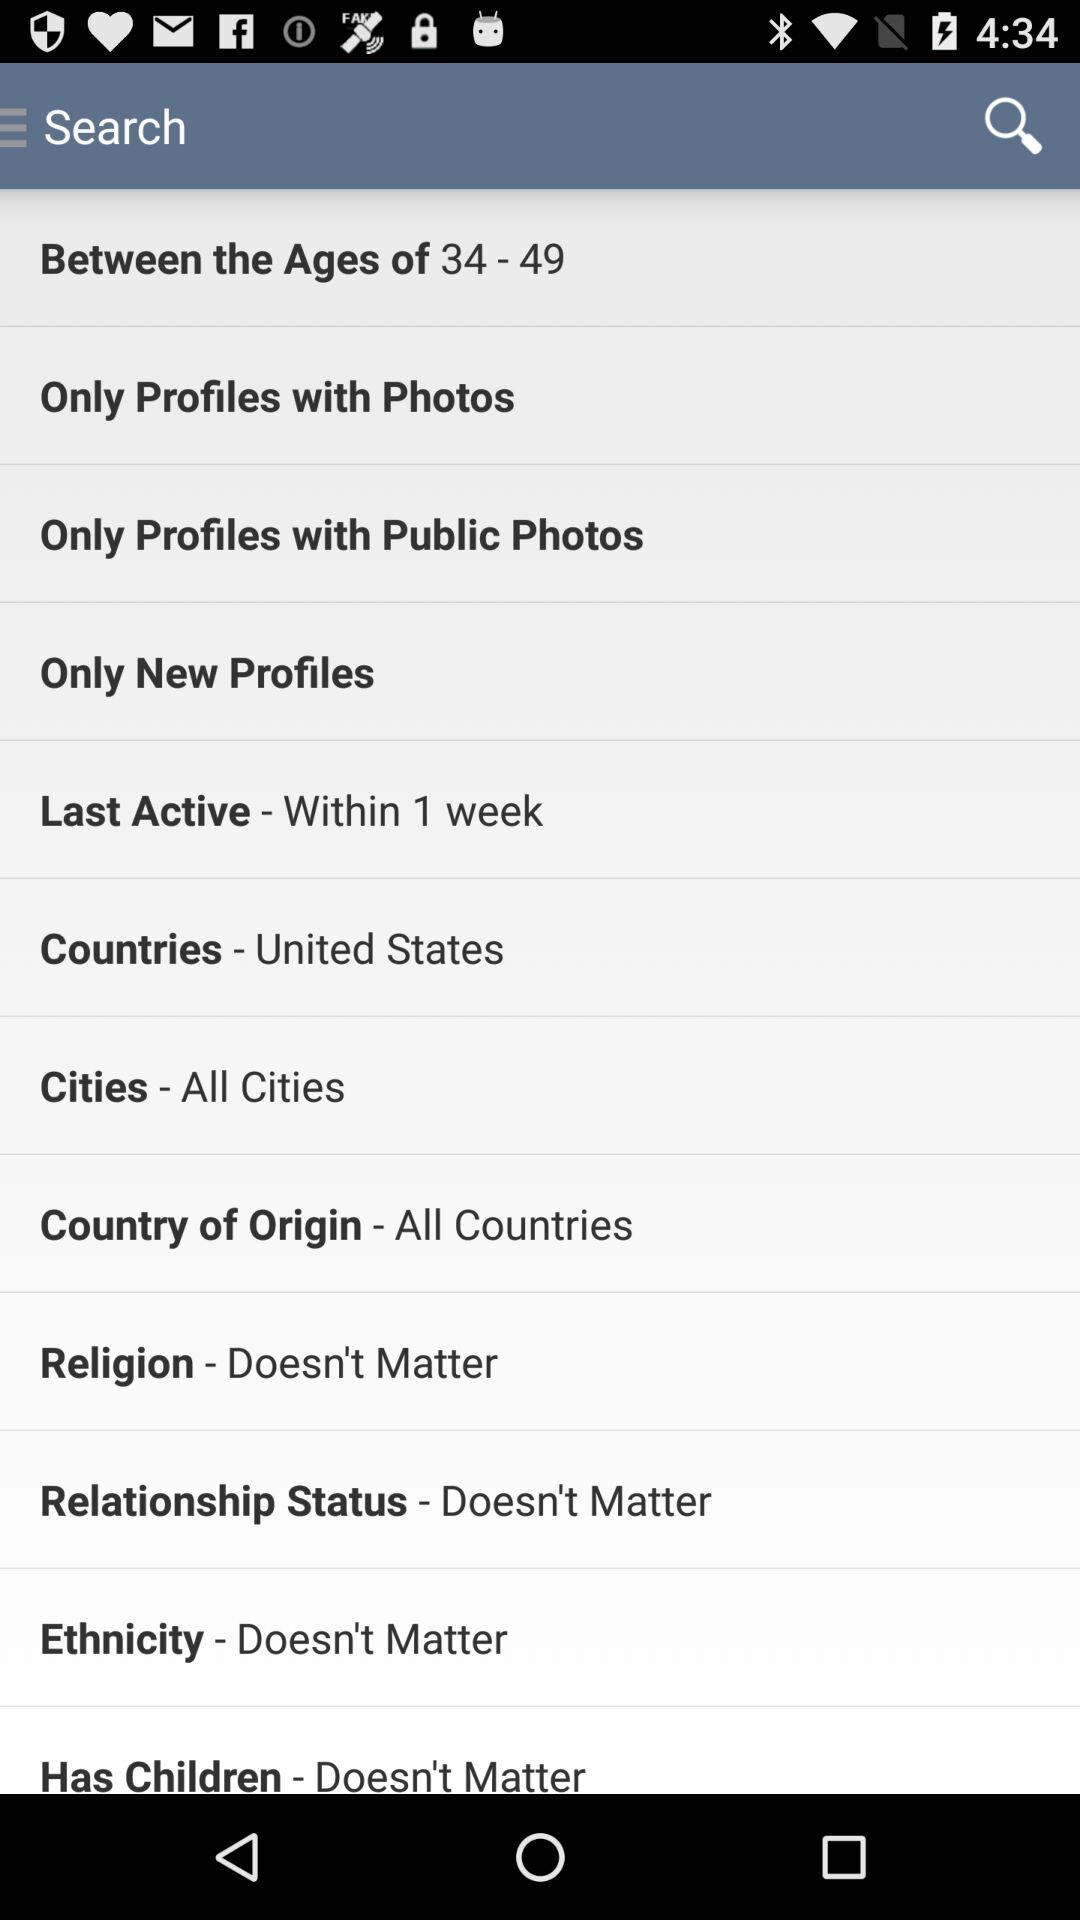What is the selected age group? The selected age group is from 34 to 49 years old. 